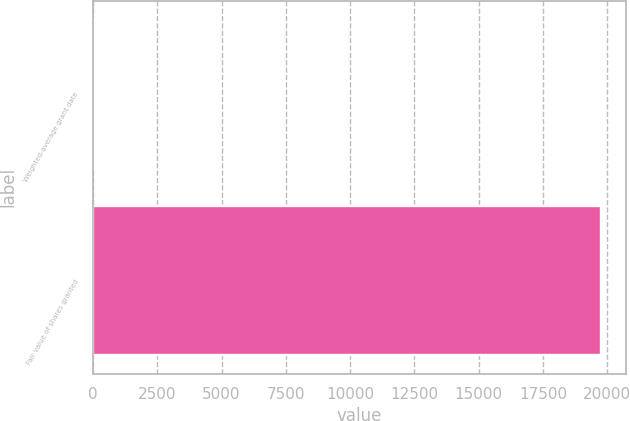Convert chart to OTSL. <chart><loc_0><loc_0><loc_500><loc_500><bar_chart><fcel>Weighted-average grant date<fcel>Fair value of shares granted<nl><fcel>52.34<fcel>19742<nl></chart> 